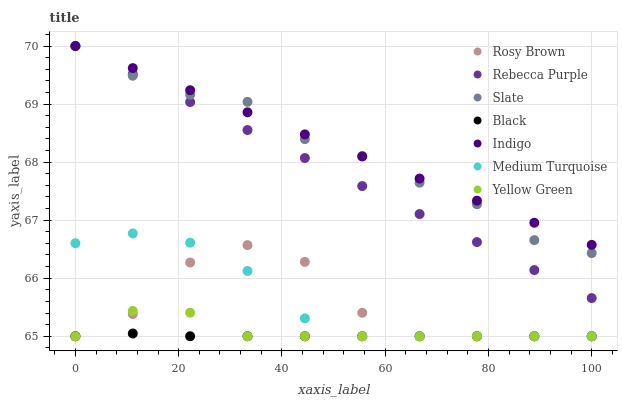Does Black have the minimum area under the curve?
Answer yes or no. Yes. Does Indigo have the maximum area under the curve?
Answer yes or no. Yes. Does Yellow Green have the minimum area under the curve?
Answer yes or no. No. Does Yellow Green have the maximum area under the curve?
Answer yes or no. No. Is Rebecca Purple the smoothest?
Answer yes or no. Yes. Is Rosy Brown the roughest?
Answer yes or no. Yes. Is Yellow Green the smoothest?
Answer yes or no. No. Is Yellow Green the roughest?
Answer yes or no. No. Does Yellow Green have the lowest value?
Answer yes or no. Yes. Does Slate have the lowest value?
Answer yes or no. No. Does Rebecca Purple have the highest value?
Answer yes or no. Yes. Does Yellow Green have the highest value?
Answer yes or no. No. Is Rosy Brown less than Rebecca Purple?
Answer yes or no. Yes. Is Indigo greater than Rosy Brown?
Answer yes or no. Yes. Does Rosy Brown intersect Yellow Green?
Answer yes or no. Yes. Is Rosy Brown less than Yellow Green?
Answer yes or no. No. Is Rosy Brown greater than Yellow Green?
Answer yes or no. No. Does Rosy Brown intersect Rebecca Purple?
Answer yes or no. No. 